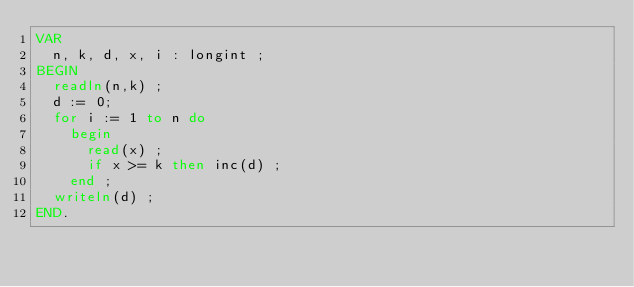<code> <loc_0><loc_0><loc_500><loc_500><_Pascal_>VAR
  n, k, d, x, i : longint ;
BEGIN
  readln(n,k) ;
  d := 0;
  for i := 1 to n do 
    begin
      read(x) ;
      if x >= k then inc(d) ;
    end ;
  writeln(d) ;
END.</code> 